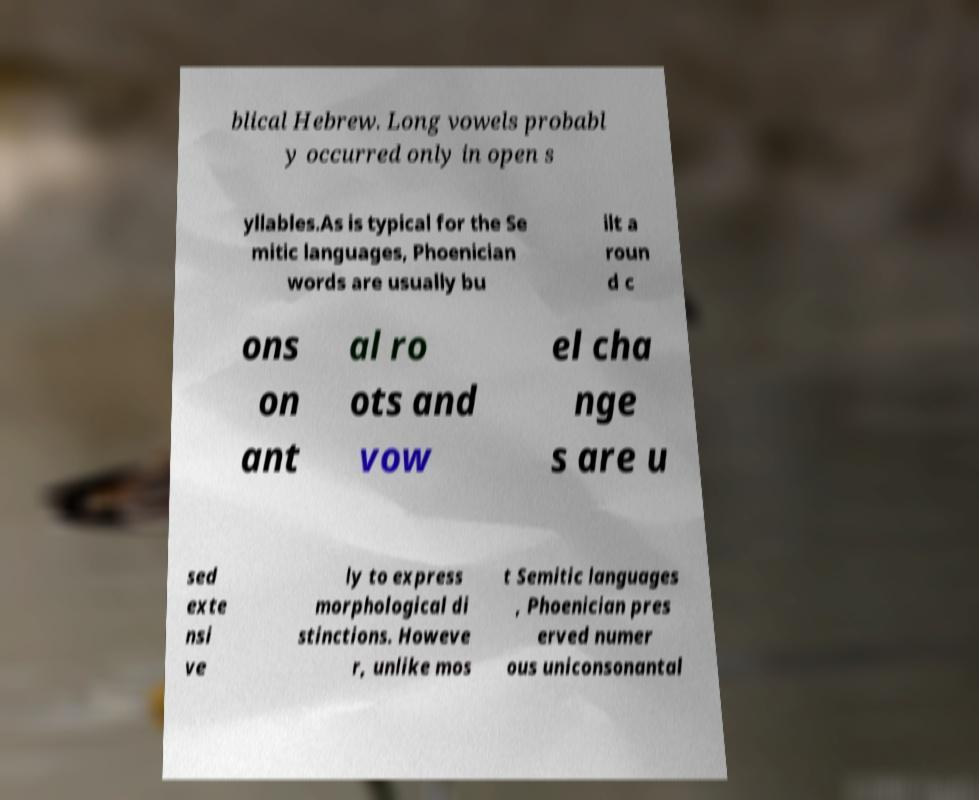Can you read and provide the text displayed in the image?This photo seems to have some interesting text. Can you extract and type it out for me? blical Hebrew. Long vowels probabl y occurred only in open s yllables.As is typical for the Se mitic languages, Phoenician words are usually bu ilt a roun d c ons on ant al ro ots and vow el cha nge s are u sed exte nsi ve ly to express morphological di stinctions. Howeve r, unlike mos t Semitic languages , Phoenician pres erved numer ous uniconsonantal 